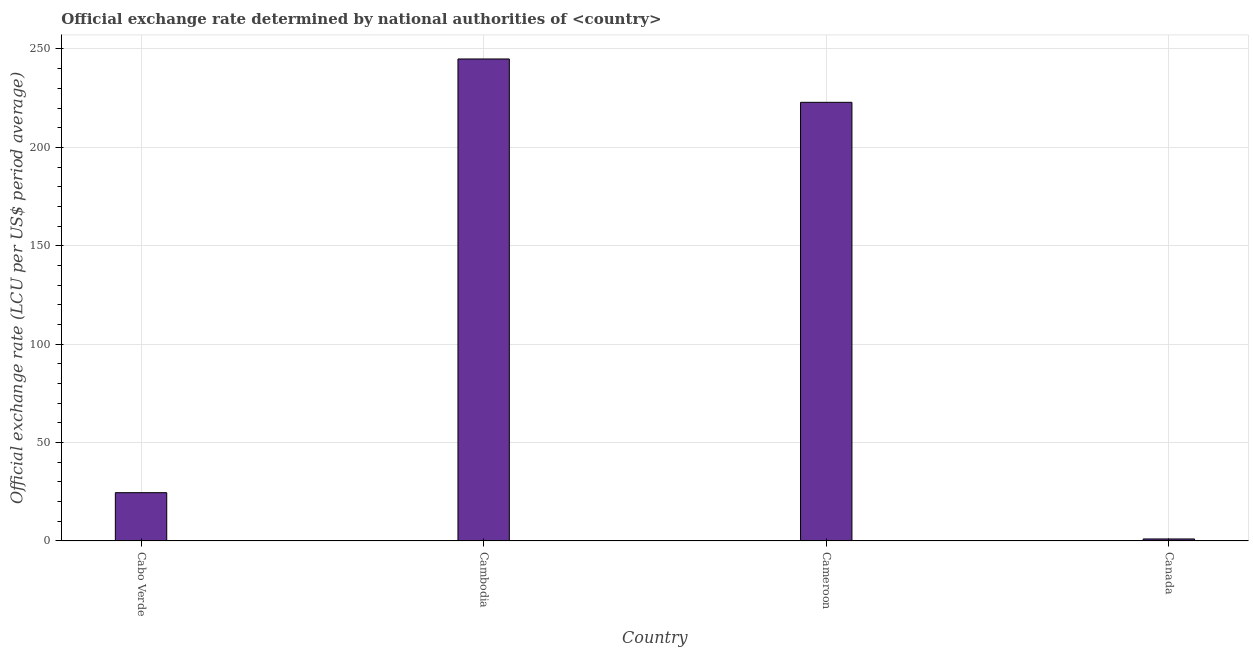Does the graph contain grids?
Give a very brief answer. Yes. What is the title of the graph?
Offer a very short reply. Official exchange rate determined by national authorities of <country>. What is the label or title of the Y-axis?
Make the answer very short. Official exchange rate (LCU per US$ period average). What is the official exchange rate in Cameroon?
Your response must be concise. 222.89. Across all countries, what is the maximum official exchange rate?
Provide a succinct answer. 244.92. Across all countries, what is the minimum official exchange rate?
Offer a terse response. 1. In which country was the official exchange rate maximum?
Your answer should be very brief. Cambodia. What is the sum of the official exchange rate?
Your answer should be compact. 493.32. What is the difference between the official exchange rate in Cabo Verde and Cameroon?
Make the answer very short. -198.37. What is the average official exchange rate per country?
Offer a very short reply. 123.33. What is the median official exchange rate?
Keep it short and to the point. 123.7. Is the official exchange rate in Cambodia less than that in Canada?
Offer a very short reply. No. What is the difference between the highest and the second highest official exchange rate?
Your answer should be very brief. 22.03. Is the sum of the official exchange rate in Cambodia and Canada greater than the maximum official exchange rate across all countries?
Your answer should be very brief. Yes. What is the difference between the highest and the lowest official exchange rate?
Your answer should be compact. 243.92. Are the values on the major ticks of Y-axis written in scientific E-notation?
Provide a succinct answer. No. What is the Official exchange rate (LCU per US$ period average) of Cabo Verde?
Keep it short and to the point. 24.52. What is the Official exchange rate (LCU per US$ period average) in Cambodia?
Give a very brief answer. 244.92. What is the Official exchange rate (LCU per US$ period average) in Cameroon?
Offer a very short reply. 222.89. What is the Official exchange rate (LCU per US$ period average) of Canada?
Make the answer very short. 1. What is the difference between the Official exchange rate (LCU per US$ period average) in Cabo Verde and Cambodia?
Offer a very short reply. -220.4. What is the difference between the Official exchange rate (LCU per US$ period average) in Cabo Verde and Cameroon?
Provide a short and direct response. -198.37. What is the difference between the Official exchange rate (LCU per US$ period average) in Cabo Verde and Canada?
Ensure brevity in your answer.  23.52. What is the difference between the Official exchange rate (LCU per US$ period average) in Cambodia and Cameroon?
Ensure brevity in your answer.  22.03. What is the difference between the Official exchange rate (LCU per US$ period average) in Cambodia and Canada?
Keep it short and to the point. 243.92. What is the difference between the Official exchange rate (LCU per US$ period average) in Cameroon and Canada?
Make the answer very short. 221.89. What is the ratio of the Official exchange rate (LCU per US$ period average) in Cabo Verde to that in Cambodia?
Provide a succinct answer. 0.1. What is the ratio of the Official exchange rate (LCU per US$ period average) in Cabo Verde to that in Cameroon?
Keep it short and to the point. 0.11. What is the ratio of the Official exchange rate (LCU per US$ period average) in Cabo Verde to that in Canada?
Your answer should be very brief. 24.51. What is the ratio of the Official exchange rate (LCU per US$ period average) in Cambodia to that in Cameroon?
Give a very brief answer. 1.1. What is the ratio of the Official exchange rate (LCU per US$ period average) in Cambodia to that in Canada?
Your response must be concise. 244.9. What is the ratio of the Official exchange rate (LCU per US$ period average) in Cameroon to that in Canada?
Your answer should be very brief. 222.87. 